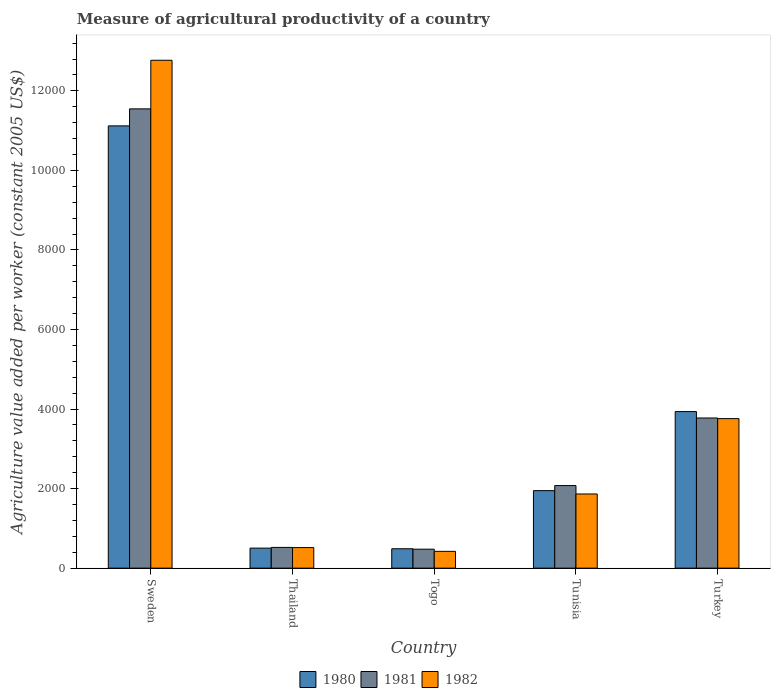How many groups of bars are there?
Make the answer very short. 5. How many bars are there on the 1st tick from the right?
Make the answer very short. 3. What is the label of the 4th group of bars from the left?
Offer a very short reply. Tunisia. In how many cases, is the number of bars for a given country not equal to the number of legend labels?
Keep it short and to the point. 0. What is the measure of agricultural productivity in 1982 in Togo?
Ensure brevity in your answer.  422.8. Across all countries, what is the maximum measure of agricultural productivity in 1982?
Make the answer very short. 1.28e+04. Across all countries, what is the minimum measure of agricultural productivity in 1980?
Your response must be concise. 487.34. In which country was the measure of agricultural productivity in 1982 maximum?
Your answer should be very brief. Sweden. In which country was the measure of agricultural productivity in 1980 minimum?
Your response must be concise. Togo. What is the total measure of agricultural productivity in 1981 in the graph?
Offer a very short reply. 1.84e+04. What is the difference between the measure of agricultural productivity in 1980 in Thailand and that in Togo?
Your response must be concise. 16.41. What is the difference between the measure of agricultural productivity in 1982 in Togo and the measure of agricultural productivity in 1981 in Sweden?
Offer a terse response. -1.11e+04. What is the average measure of agricultural productivity in 1980 per country?
Your answer should be compact. 3598.98. What is the difference between the measure of agricultural productivity of/in 1980 and measure of agricultural productivity of/in 1981 in Thailand?
Keep it short and to the point. -17.34. In how many countries, is the measure of agricultural productivity in 1980 greater than 10800 US$?
Keep it short and to the point. 1. What is the ratio of the measure of agricultural productivity in 1980 in Sweden to that in Turkey?
Your response must be concise. 2.82. Is the measure of agricultural productivity in 1980 in Tunisia less than that in Turkey?
Offer a very short reply. Yes. What is the difference between the highest and the second highest measure of agricultural productivity in 1980?
Make the answer very short. 1987.52. What is the difference between the highest and the lowest measure of agricultural productivity in 1982?
Ensure brevity in your answer.  1.23e+04. Is the sum of the measure of agricultural productivity in 1981 in Thailand and Tunisia greater than the maximum measure of agricultural productivity in 1980 across all countries?
Offer a terse response. No. What does the 1st bar from the left in Thailand represents?
Offer a terse response. 1980. Is it the case that in every country, the sum of the measure of agricultural productivity in 1982 and measure of agricultural productivity in 1981 is greater than the measure of agricultural productivity in 1980?
Provide a short and direct response. Yes. Are all the bars in the graph horizontal?
Keep it short and to the point. No. How many countries are there in the graph?
Offer a very short reply. 5. What is the difference between two consecutive major ticks on the Y-axis?
Ensure brevity in your answer.  2000. Does the graph contain grids?
Make the answer very short. No. How are the legend labels stacked?
Give a very brief answer. Horizontal. What is the title of the graph?
Your response must be concise. Measure of agricultural productivity of a country. Does "1990" appear as one of the legend labels in the graph?
Make the answer very short. No. What is the label or title of the Y-axis?
Your answer should be compact. Agriculture value added per worker (constant 2005 US$). What is the Agriculture value added per worker (constant 2005 US$) of 1980 in Sweden?
Your answer should be compact. 1.11e+04. What is the Agriculture value added per worker (constant 2005 US$) of 1981 in Sweden?
Keep it short and to the point. 1.15e+04. What is the Agriculture value added per worker (constant 2005 US$) in 1982 in Sweden?
Keep it short and to the point. 1.28e+04. What is the Agriculture value added per worker (constant 2005 US$) in 1980 in Thailand?
Keep it short and to the point. 503.75. What is the Agriculture value added per worker (constant 2005 US$) in 1981 in Thailand?
Give a very brief answer. 521.09. What is the Agriculture value added per worker (constant 2005 US$) in 1982 in Thailand?
Offer a very short reply. 517.06. What is the Agriculture value added per worker (constant 2005 US$) of 1980 in Togo?
Your answer should be compact. 487.34. What is the Agriculture value added per worker (constant 2005 US$) in 1981 in Togo?
Provide a succinct answer. 476.73. What is the Agriculture value added per worker (constant 2005 US$) in 1982 in Togo?
Keep it short and to the point. 422.8. What is the Agriculture value added per worker (constant 2005 US$) in 1980 in Tunisia?
Offer a terse response. 1948.63. What is the Agriculture value added per worker (constant 2005 US$) in 1981 in Tunisia?
Your response must be concise. 2075.93. What is the Agriculture value added per worker (constant 2005 US$) in 1982 in Tunisia?
Your answer should be very brief. 1864.56. What is the Agriculture value added per worker (constant 2005 US$) in 1980 in Turkey?
Offer a terse response. 3936.15. What is the Agriculture value added per worker (constant 2005 US$) of 1981 in Turkey?
Offer a terse response. 3775.17. What is the Agriculture value added per worker (constant 2005 US$) in 1982 in Turkey?
Offer a terse response. 3759.31. Across all countries, what is the maximum Agriculture value added per worker (constant 2005 US$) of 1980?
Offer a very short reply. 1.11e+04. Across all countries, what is the maximum Agriculture value added per worker (constant 2005 US$) in 1981?
Your answer should be very brief. 1.15e+04. Across all countries, what is the maximum Agriculture value added per worker (constant 2005 US$) in 1982?
Offer a very short reply. 1.28e+04. Across all countries, what is the minimum Agriculture value added per worker (constant 2005 US$) in 1980?
Make the answer very short. 487.34. Across all countries, what is the minimum Agriculture value added per worker (constant 2005 US$) of 1981?
Give a very brief answer. 476.73. Across all countries, what is the minimum Agriculture value added per worker (constant 2005 US$) in 1982?
Make the answer very short. 422.8. What is the total Agriculture value added per worker (constant 2005 US$) in 1980 in the graph?
Give a very brief answer. 1.80e+04. What is the total Agriculture value added per worker (constant 2005 US$) of 1981 in the graph?
Provide a short and direct response. 1.84e+04. What is the total Agriculture value added per worker (constant 2005 US$) of 1982 in the graph?
Your answer should be very brief. 1.93e+04. What is the difference between the Agriculture value added per worker (constant 2005 US$) in 1980 in Sweden and that in Thailand?
Provide a short and direct response. 1.06e+04. What is the difference between the Agriculture value added per worker (constant 2005 US$) of 1981 in Sweden and that in Thailand?
Your answer should be very brief. 1.10e+04. What is the difference between the Agriculture value added per worker (constant 2005 US$) in 1982 in Sweden and that in Thailand?
Your answer should be compact. 1.23e+04. What is the difference between the Agriculture value added per worker (constant 2005 US$) of 1980 in Sweden and that in Togo?
Provide a succinct answer. 1.06e+04. What is the difference between the Agriculture value added per worker (constant 2005 US$) in 1981 in Sweden and that in Togo?
Make the answer very short. 1.11e+04. What is the difference between the Agriculture value added per worker (constant 2005 US$) of 1982 in Sweden and that in Togo?
Offer a terse response. 1.23e+04. What is the difference between the Agriculture value added per worker (constant 2005 US$) of 1980 in Sweden and that in Tunisia?
Your answer should be compact. 9170.42. What is the difference between the Agriculture value added per worker (constant 2005 US$) in 1981 in Sweden and that in Tunisia?
Give a very brief answer. 9470.63. What is the difference between the Agriculture value added per worker (constant 2005 US$) in 1982 in Sweden and that in Tunisia?
Your answer should be compact. 1.09e+04. What is the difference between the Agriculture value added per worker (constant 2005 US$) of 1980 in Sweden and that in Turkey?
Offer a terse response. 7182.91. What is the difference between the Agriculture value added per worker (constant 2005 US$) of 1981 in Sweden and that in Turkey?
Your answer should be compact. 7771.39. What is the difference between the Agriculture value added per worker (constant 2005 US$) in 1982 in Sweden and that in Turkey?
Keep it short and to the point. 9009.17. What is the difference between the Agriculture value added per worker (constant 2005 US$) in 1980 in Thailand and that in Togo?
Make the answer very short. 16.41. What is the difference between the Agriculture value added per worker (constant 2005 US$) of 1981 in Thailand and that in Togo?
Your answer should be compact. 44.37. What is the difference between the Agriculture value added per worker (constant 2005 US$) in 1982 in Thailand and that in Togo?
Provide a succinct answer. 94.26. What is the difference between the Agriculture value added per worker (constant 2005 US$) of 1980 in Thailand and that in Tunisia?
Your answer should be very brief. -1444.88. What is the difference between the Agriculture value added per worker (constant 2005 US$) of 1981 in Thailand and that in Tunisia?
Your answer should be compact. -1554.83. What is the difference between the Agriculture value added per worker (constant 2005 US$) in 1982 in Thailand and that in Tunisia?
Your response must be concise. -1347.5. What is the difference between the Agriculture value added per worker (constant 2005 US$) of 1980 in Thailand and that in Turkey?
Provide a succinct answer. -3432.39. What is the difference between the Agriculture value added per worker (constant 2005 US$) in 1981 in Thailand and that in Turkey?
Make the answer very short. -3254.08. What is the difference between the Agriculture value added per worker (constant 2005 US$) in 1982 in Thailand and that in Turkey?
Offer a very short reply. -3242.25. What is the difference between the Agriculture value added per worker (constant 2005 US$) of 1980 in Togo and that in Tunisia?
Provide a succinct answer. -1461.29. What is the difference between the Agriculture value added per worker (constant 2005 US$) in 1981 in Togo and that in Tunisia?
Ensure brevity in your answer.  -1599.2. What is the difference between the Agriculture value added per worker (constant 2005 US$) in 1982 in Togo and that in Tunisia?
Provide a succinct answer. -1441.76. What is the difference between the Agriculture value added per worker (constant 2005 US$) of 1980 in Togo and that in Turkey?
Ensure brevity in your answer.  -3448.81. What is the difference between the Agriculture value added per worker (constant 2005 US$) of 1981 in Togo and that in Turkey?
Your answer should be very brief. -3298.45. What is the difference between the Agriculture value added per worker (constant 2005 US$) of 1982 in Togo and that in Turkey?
Keep it short and to the point. -3336.51. What is the difference between the Agriculture value added per worker (constant 2005 US$) in 1980 in Tunisia and that in Turkey?
Keep it short and to the point. -1987.52. What is the difference between the Agriculture value added per worker (constant 2005 US$) of 1981 in Tunisia and that in Turkey?
Your response must be concise. -1699.25. What is the difference between the Agriculture value added per worker (constant 2005 US$) in 1982 in Tunisia and that in Turkey?
Give a very brief answer. -1894.75. What is the difference between the Agriculture value added per worker (constant 2005 US$) of 1980 in Sweden and the Agriculture value added per worker (constant 2005 US$) of 1981 in Thailand?
Provide a short and direct response. 1.06e+04. What is the difference between the Agriculture value added per worker (constant 2005 US$) of 1980 in Sweden and the Agriculture value added per worker (constant 2005 US$) of 1982 in Thailand?
Your answer should be compact. 1.06e+04. What is the difference between the Agriculture value added per worker (constant 2005 US$) of 1981 in Sweden and the Agriculture value added per worker (constant 2005 US$) of 1982 in Thailand?
Give a very brief answer. 1.10e+04. What is the difference between the Agriculture value added per worker (constant 2005 US$) in 1980 in Sweden and the Agriculture value added per worker (constant 2005 US$) in 1981 in Togo?
Your response must be concise. 1.06e+04. What is the difference between the Agriculture value added per worker (constant 2005 US$) of 1980 in Sweden and the Agriculture value added per worker (constant 2005 US$) of 1982 in Togo?
Your answer should be compact. 1.07e+04. What is the difference between the Agriculture value added per worker (constant 2005 US$) in 1981 in Sweden and the Agriculture value added per worker (constant 2005 US$) in 1982 in Togo?
Offer a very short reply. 1.11e+04. What is the difference between the Agriculture value added per worker (constant 2005 US$) of 1980 in Sweden and the Agriculture value added per worker (constant 2005 US$) of 1981 in Tunisia?
Give a very brief answer. 9043.12. What is the difference between the Agriculture value added per worker (constant 2005 US$) in 1980 in Sweden and the Agriculture value added per worker (constant 2005 US$) in 1982 in Tunisia?
Your answer should be compact. 9254.49. What is the difference between the Agriculture value added per worker (constant 2005 US$) of 1981 in Sweden and the Agriculture value added per worker (constant 2005 US$) of 1982 in Tunisia?
Make the answer very short. 9682. What is the difference between the Agriculture value added per worker (constant 2005 US$) of 1980 in Sweden and the Agriculture value added per worker (constant 2005 US$) of 1981 in Turkey?
Give a very brief answer. 7343.88. What is the difference between the Agriculture value added per worker (constant 2005 US$) in 1980 in Sweden and the Agriculture value added per worker (constant 2005 US$) in 1982 in Turkey?
Keep it short and to the point. 7359.74. What is the difference between the Agriculture value added per worker (constant 2005 US$) in 1981 in Sweden and the Agriculture value added per worker (constant 2005 US$) in 1982 in Turkey?
Provide a short and direct response. 7787.25. What is the difference between the Agriculture value added per worker (constant 2005 US$) of 1980 in Thailand and the Agriculture value added per worker (constant 2005 US$) of 1981 in Togo?
Give a very brief answer. 27.02. What is the difference between the Agriculture value added per worker (constant 2005 US$) in 1980 in Thailand and the Agriculture value added per worker (constant 2005 US$) in 1982 in Togo?
Offer a very short reply. 80.96. What is the difference between the Agriculture value added per worker (constant 2005 US$) in 1981 in Thailand and the Agriculture value added per worker (constant 2005 US$) in 1982 in Togo?
Offer a very short reply. 98.3. What is the difference between the Agriculture value added per worker (constant 2005 US$) in 1980 in Thailand and the Agriculture value added per worker (constant 2005 US$) in 1981 in Tunisia?
Provide a short and direct response. -1572.17. What is the difference between the Agriculture value added per worker (constant 2005 US$) in 1980 in Thailand and the Agriculture value added per worker (constant 2005 US$) in 1982 in Tunisia?
Provide a succinct answer. -1360.8. What is the difference between the Agriculture value added per worker (constant 2005 US$) of 1981 in Thailand and the Agriculture value added per worker (constant 2005 US$) of 1982 in Tunisia?
Keep it short and to the point. -1343.46. What is the difference between the Agriculture value added per worker (constant 2005 US$) in 1980 in Thailand and the Agriculture value added per worker (constant 2005 US$) in 1981 in Turkey?
Offer a very short reply. -3271.42. What is the difference between the Agriculture value added per worker (constant 2005 US$) in 1980 in Thailand and the Agriculture value added per worker (constant 2005 US$) in 1982 in Turkey?
Ensure brevity in your answer.  -3255.56. What is the difference between the Agriculture value added per worker (constant 2005 US$) in 1981 in Thailand and the Agriculture value added per worker (constant 2005 US$) in 1982 in Turkey?
Your answer should be compact. -3238.22. What is the difference between the Agriculture value added per worker (constant 2005 US$) in 1980 in Togo and the Agriculture value added per worker (constant 2005 US$) in 1981 in Tunisia?
Ensure brevity in your answer.  -1588.59. What is the difference between the Agriculture value added per worker (constant 2005 US$) in 1980 in Togo and the Agriculture value added per worker (constant 2005 US$) in 1982 in Tunisia?
Keep it short and to the point. -1377.22. What is the difference between the Agriculture value added per worker (constant 2005 US$) of 1981 in Togo and the Agriculture value added per worker (constant 2005 US$) of 1982 in Tunisia?
Offer a terse response. -1387.83. What is the difference between the Agriculture value added per worker (constant 2005 US$) of 1980 in Togo and the Agriculture value added per worker (constant 2005 US$) of 1981 in Turkey?
Offer a very short reply. -3287.83. What is the difference between the Agriculture value added per worker (constant 2005 US$) in 1980 in Togo and the Agriculture value added per worker (constant 2005 US$) in 1982 in Turkey?
Offer a very short reply. -3271.97. What is the difference between the Agriculture value added per worker (constant 2005 US$) in 1981 in Togo and the Agriculture value added per worker (constant 2005 US$) in 1982 in Turkey?
Ensure brevity in your answer.  -3282.58. What is the difference between the Agriculture value added per worker (constant 2005 US$) of 1980 in Tunisia and the Agriculture value added per worker (constant 2005 US$) of 1981 in Turkey?
Make the answer very short. -1826.54. What is the difference between the Agriculture value added per worker (constant 2005 US$) of 1980 in Tunisia and the Agriculture value added per worker (constant 2005 US$) of 1982 in Turkey?
Ensure brevity in your answer.  -1810.68. What is the difference between the Agriculture value added per worker (constant 2005 US$) in 1981 in Tunisia and the Agriculture value added per worker (constant 2005 US$) in 1982 in Turkey?
Offer a very short reply. -1683.38. What is the average Agriculture value added per worker (constant 2005 US$) in 1980 per country?
Your answer should be very brief. 3598.98. What is the average Agriculture value added per worker (constant 2005 US$) in 1981 per country?
Offer a terse response. 3679.1. What is the average Agriculture value added per worker (constant 2005 US$) in 1982 per country?
Provide a succinct answer. 3866.44. What is the difference between the Agriculture value added per worker (constant 2005 US$) of 1980 and Agriculture value added per worker (constant 2005 US$) of 1981 in Sweden?
Provide a succinct answer. -427.51. What is the difference between the Agriculture value added per worker (constant 2005 US$) of 1980 and Agriculture value added per worker (constant 2005 US$) of 1982 in Sweden?
Ensure brevity in your answer.  -1649.43. What is the difference between the Agriculture value added per worker (constant 2005 US$) of 1981 and Agriculture value added per worker (constant 2005 US$) of 1982 in Sweden?
Keep it short and to the point. -1221.92. What is the difference between the Agriculture value added per worker (constant 2005 US$) of 1980 and Agriculture value added per worker (constant 2005 US$) of 1981 in Thailand?
Provide a short and direct response. -17.34. What is the difference between the Agriculture value added per worker (constant 2005 US$) in 1980 and Agriculture value added per worker (constant 2005 US$) in 1982 in Thailand?
Your response must be concise. -13.31. What is the difference between the Agriculture value added per worker (constant 2005 US$) in 1981 and Agriculture value added per worker (constant 2005 US$) in 1982 in Thailand?
Provide a short and direct response. 4.03. What is the difference between the Agriculture value added per worker (constant 2005 US$) of 1980 and Agriculture value added per worker (constant 2005 US$) of 1981 in Togo?
Provide a short and direct response. 10.61. What is the difference between the Agriculture value added per worker (constant 2005 US$) of 1980 and Agriculture value added per worker (constant 2005 US$) of 1982 in Togo?
Provide a short and direct response. 64.54. What is the difference between the Agriculture value added per worker (constant 2005 US$) in 1981 and Agriculture value added per worker (constant 2005 US$) in 1982 in Togo?
Keep it short and to the point. 53.93. What is the difference between the Agriculture value added per worker (constant 2005 US$) of 1980 and Agriculture value added per worker (constant 2005 US$) of 1981 in Tunisia?
Provide a short and direct response. -127.3. What is the difference between the Agriculture value added per worker (constant 2005 US$) of 1980 and Agriculture value added per worker (constant 2005 US$) of 1982 in Tunisia?
Offer a terse response. 84.07. What is the difference between the Agriculture value added per worker (constant 2005 US$) of 1981 and Agriculture value added per worker (constant 2005 US$) of 1982 in Tunisia?
Give a very brief answer. 211.37. What is the difference between the Agriculture value added per worker (constant 2005 US$) in 1980 and Agriculture value added per worker (constant 2005 US$) in 1981 in Turkey?
Your answer should be compact. 160.97. What is the difference between the Agriculture value added per worker (constant 2005 US$) of 1980 and Agriculture value added per worker (constant 2005 US$) of 1982 in Turkey?
Provide a succinct answer. 176.84. What is the difference between the Agriculture value added per worker (constant 2005 US$) of 1981 and Agriculture value added per worker (constant 2005 US$) of 1982 in Turkey?
Provide a succinct answer. 15.86. What is the ratio of the Agriculture value added per worker (constant 2005 US$) of 1980 in Sweden to that in Thailand?
Offer a terse response. 22.07. What is the ratio of the Agriculture value added per worker (constant 2005 US$) of 1981 in Sweden to that in Thailand?
Your answer should be very brief. 22.16. What is the ratio of the Agriculture value added per worker (constant 2005 US$) of 1982 in Sweden to that in Thailand?
Your answer should be compact. 24.69. What is the ratio of the Agriculture value added per worker (constant 2005 US$) of 1980 in Sweden to that in Togo?
Offer a terse response. 22.82. What is the ratio of the Agriculture value added per worker (constant 2005 US$) in 1981 in Sweden to that in Togo?
Give a very brief answer. 24.22. What is the ratio of the Agriculture value added per worker (constant 2005 US$) of 1982 in Sweden to that in Togo?
Keep it short and to the point. 30.2. What is the ratio of the Agriculture value added per worker (constant 2005 US$) of 1980 in Sweden to that in Tunisia?
Offer a very short reply. 5.71. What is the ratio of the Agriculture value added per worker (constant 2005 US$) in 1981 in Sweden to that in Tunisia?
Make the answer very short. 5.56. What is the ratio of the Agriculture value added per worker (constant 2005 US$) of 1982 in Sweden to that in Tunisia?
Offer a very short reply. 6.85. What is the ratio of the Agriculture value added per worker (constant 2005 US$) of 1980 in Sweden to that in Turkey?
Offer a terse response. 2.82. What is the ratio of the Agriculture value added per worker (constant 2005 US$) in 1981 in Sweden to that in Turkey?
Offer a very short reply. 3.06. What is the ratio of the Agriculture value added per worker (constant 2005 US$) in 1982 in Sweden to that in Turkey?
Offer a terse response. 3.4. What is the ratio of the Agriculture value added per worker (constant 2005 US$) of 1980 in Thailand to that in Togo?
Your answer should be compact. 1.03. What is the ratio of the Agriculture value added per worker (constant 2005 US$) of 1981 in Thailand to that in Togo?
Keep it short and to the point. 1.09. What is the ratio of the Agriculture value added per worker (constant 2005 US$) of 1982 in Thailand to that in Togo?
Ensure brevity in your answer.  1.22. What is the ratio of the Agriculture value added per worker (constant 2005 US$) in 1980 in Thailand to that in Tunisia?
Offer a very short reply. 0.26. What is the ratio of the Agriculture value added per worker (constant 2005 US$) in 1981 in Thailand to that in Tunisia?
Your response must be concise. 0.25. What is the ratio of the Agriculture value added per worker (constant 2005 US$) in 1982 in Thailand to that in Tunisia?
Provide a succinct answer. 0.28. What is the ratio of the Agriculture value added per worker (constant 2005 US$) in 1980 in Thailand to that in Turkey?
Provide a short and direct response. 0.13. What is the ratio of the Agriculture value added per worker (constant 2005 US$) of 1981 in Thailand to that in Turkey?
Give a very brief answer. 0.14. What is the ratio of the Agriculture value added per worker (constant 2005 US$) in 1982 in Thailand to that in Turkey?
Offer a very short reply. 0.14. What is the ratio of the Agriculture value added per worker (constant 2005 US$) of 1980 in Togo to that in Tunisia?
Your answer should be compact. 0.25. What is the ratio of the Agriculture value added per worker (constant 2005 US$) of 1981 in Togo to that in Tunisia?
Offer a very short reply. 0.23. What is the ratio of the Agriculture value added per worker (constant 2005 US$) in 1982 in Togo to that in Tunisia?
Provide a succinct answer. 0.23. What is the ratio of the Agriculture value added per worker (constant 2005 US$) of 1980 in Togo to that in Turkey?
Your response must be concise. 0.12. What is the ratio of the Agriculture value added per worker (constant 2005 US$) of 1981 in Togo to that in Turkey?
Keep it short and to the point. 0.13. What is the ratio of the Agriculture value added per worker (constant 2005 US$) of 1982 in Togo to that in Turkey?
Provide a short and direct response. 0.11. What is the ratio of the Agriculture value added per worker (constant 2005 US$) in 1980 in Tunisia to that in Turkey?
Provide a short and direct response. 0.5. What is the ratio of the Agriculture value added per worker (constant 2005 US$) in 1981 in Tunisia to that in Turkey?
Your response must be concise. 0.55. What is the ratio of the Agriculture value added per worker (constant 2005 US$) of 1982 in Tunisia to that in Turkey?
Offer a very short reply. 0.5. What is the difference between the highest and the second highest Agriculture value added per worker (constant 2005 US$) in 1980?
Your answer should be very brief. 7182.91. What is the difference between the highest and the second highest Agriculture value added per worker (constant 2005 US$) in 1981?
Ensure brevity in your answer.  7771.39. What is the difference between the highest and the second highest Agriculture value added per worker (constant 2005 US$) of 1982?
Provide a succinct answer. 9009.17. What is the difference between the highest and the lowest Agriculture value added per worker (constant 2005 US$) of 1980?
Your response must be concise. 1.06e+04. What is the difference between the highest and the lowest Agriculture value added per worker (constant 2005 US$) in 1981?
Keep it short and to the point. 1.11e+04. What is the difference between the highest and the lowest Agriculture value added per worker (constant 2005 US$) in 1982?
Provide a short and direct response. 1.23e+04. 